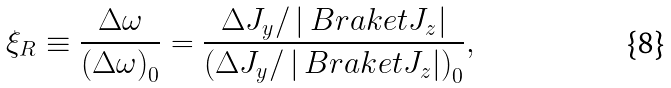<formula> <loc_0><loc_0><loc_500><loc_500>\xi _ { R } \equiv \frac { \Delta \omega } { \left ( \Delta \omega \right ) _ { 0 } } = \frac { \Delta J _ { y } / \left | \ B r a k e t { J _ { z } } \right | } { \left ( \Delta J _ { y } / \left | \ B r a k e t { J _ { z } } \right | \right ) _ { 0 } } ,</formula> 